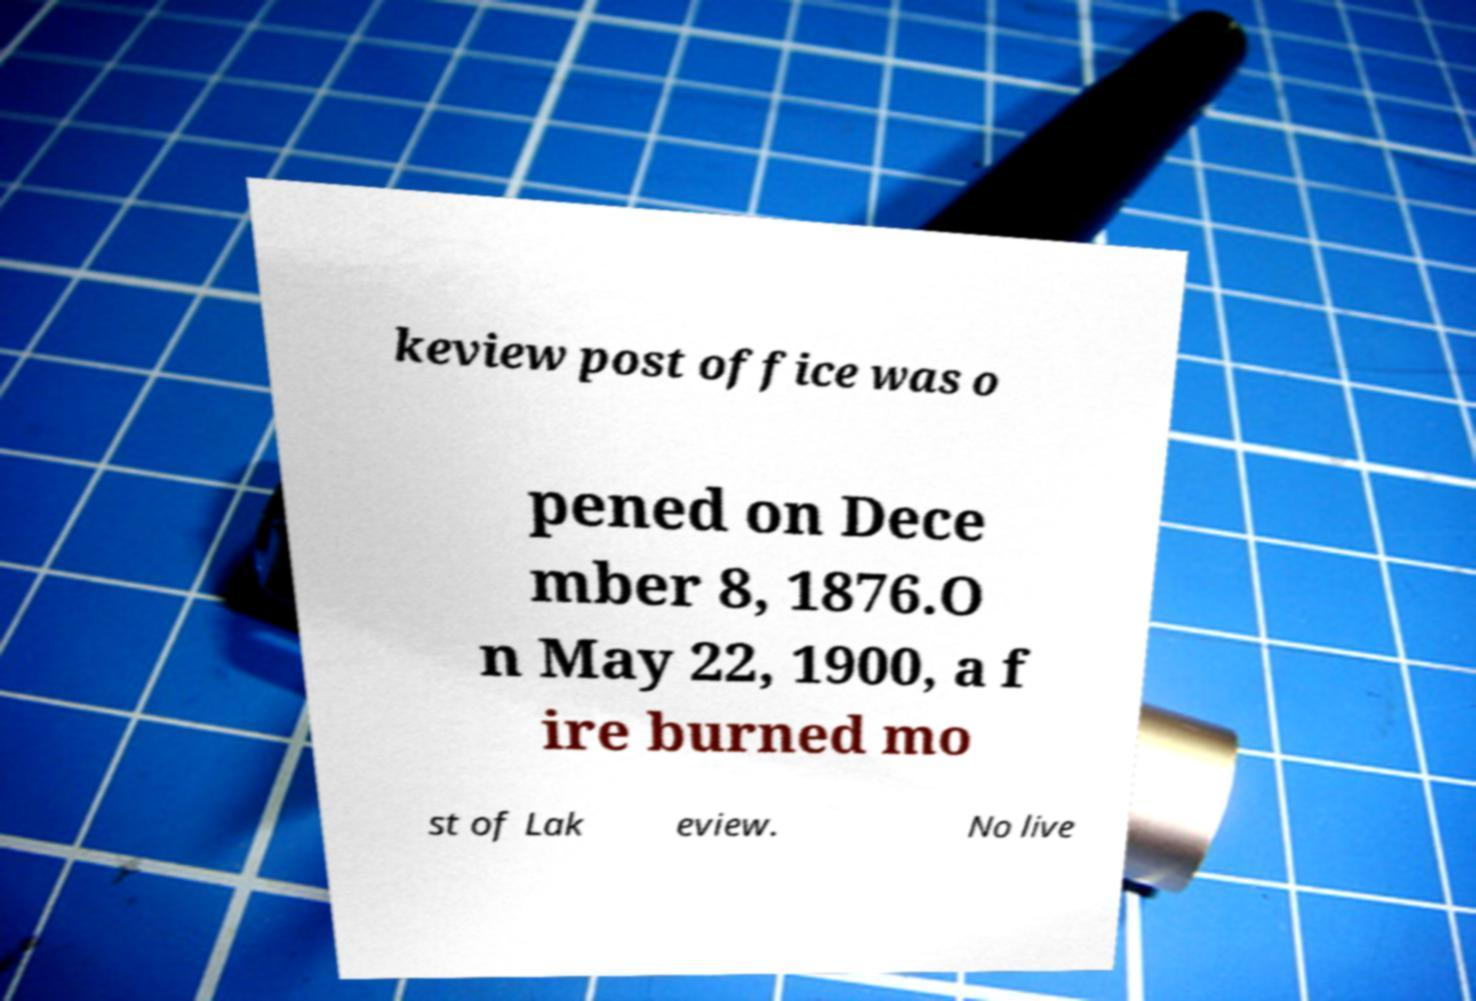Can you read and provide the text displayed in the image?This photo seems to have some interesting text. Can you extract and type it out for me? keview post office was o pened on Dece mber 8, 1876.O n May 22, 1900, a f ire burned mo st of Lak eview. No live 